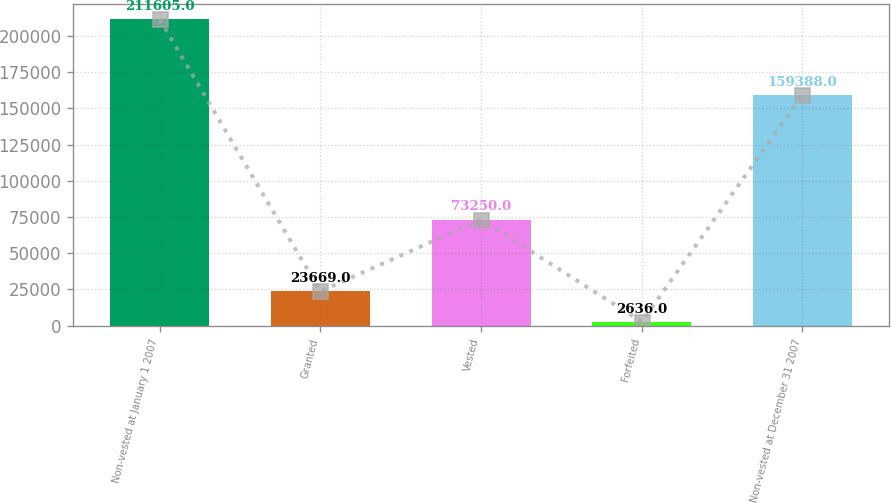Convert chart to OTSL. <chart><loc_0><loc_0><loc_500><loc_500><bar_chart><fcel>Non-vested at January 1 2007<fcel>Granted<fcel>Vested<fcel>Forfeited<fcel>Non-vested at December 31 2007<nl><fcel>211605<fcel>23669<fcel>73250<fcel>2636<fcel>159388<nl></chart> 